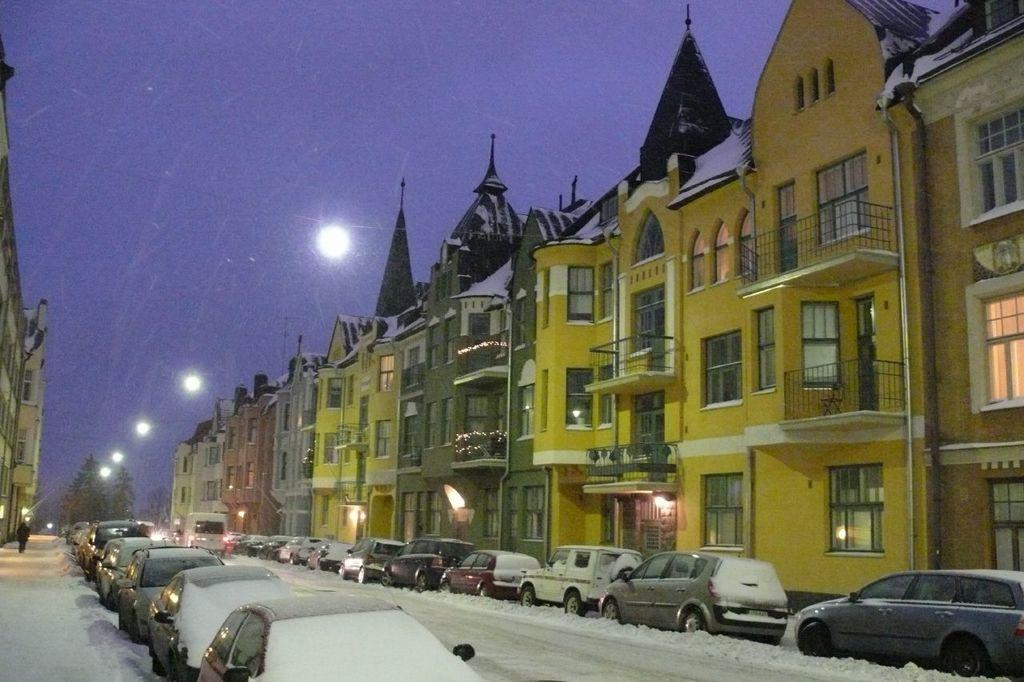What is covering the vehicles in the image? The vehicles are covered with snow. What can be seen in the background of the image? There are buildings, lights, trees, and the sky visible in the background of the image. How many vehicles are parked on the path in the image? The number of vehicles is not specified, but there are vehicles parked on the path. What type of texture can be felt on the seashore in the image? There is no seashore present in the image; it features vehicles covered with snow and a background with buildings, lights, trees, and the sky. 